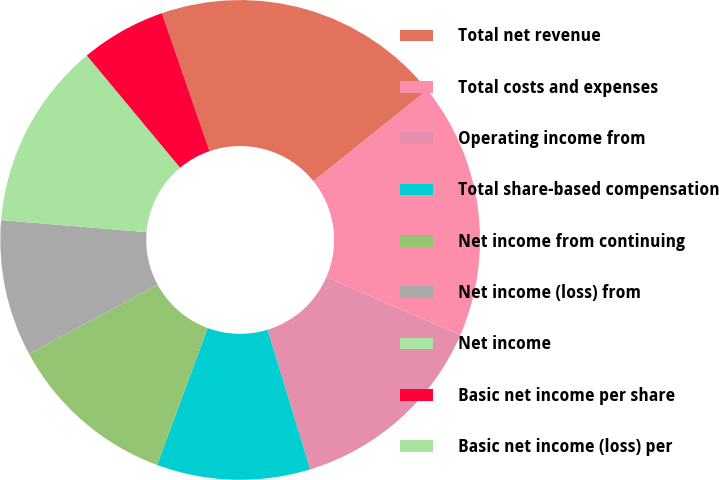Convert chart to OTSL. <chart><loc_0><loc_0><loc_500><loc_500><pie_chart><fcel>Total net revenue<fcel>Total costs and expenses<fcel>Operating income from<fcel>Total share-based compensation<fcel>Net income from continuing<fcel>Net income (loss) from<fcel>Net income<fcel>Basic net income per share<fcel>Basic net income (loss) per<nl><fcel>19.54%<fcel>17.24%<fcel>13.79%<fcel>10.34%<fcel>11.49%<fcel>9.2%<fcel>12.64%<fcel>5.75%<fcel>0.0%<nl></chart> 